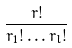<formula> <loc_0><loc_0><loc_500><loc_500>\frac { r ! } { r _ { 1 } ! \dots r _ { l } ! }</formula> 